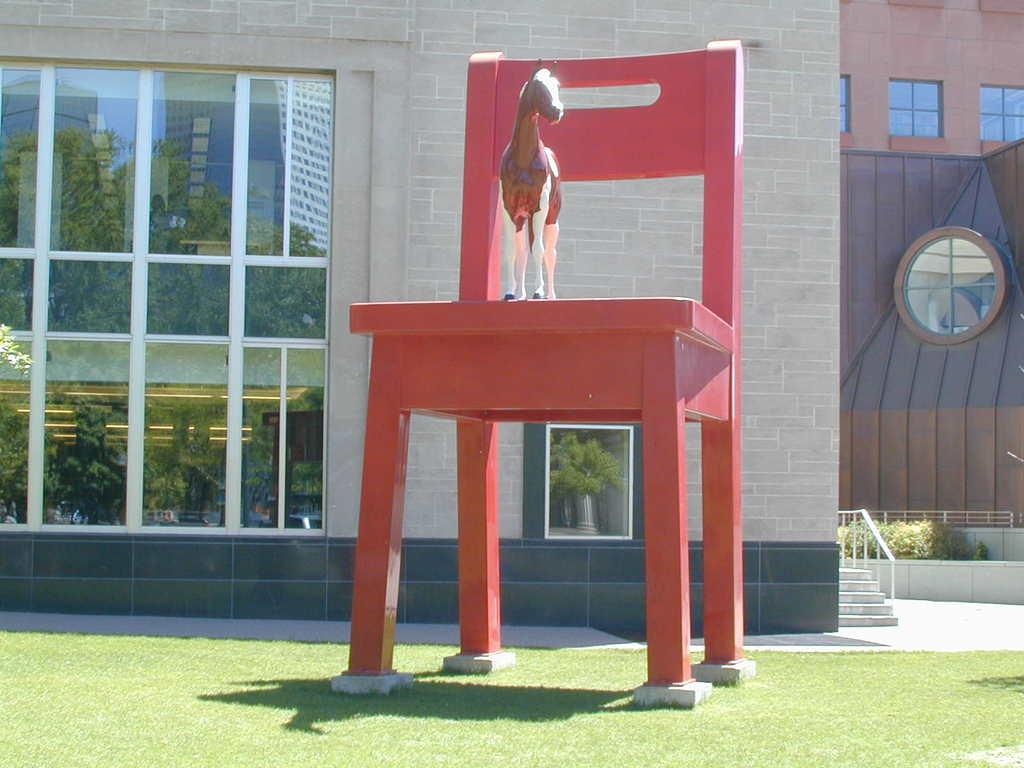What object is placed on the chair in the image? There is a toy horse on a chair in the image. What can be seen in the distance behind the chair? There is a building, plants, and stairs in the background of the image. What is visible at the bottom of the image? The ground is visible at the bottom of the image. What type of tin is being used to show respect in the image? There is no tin or any indication of respect being shown in the image. 